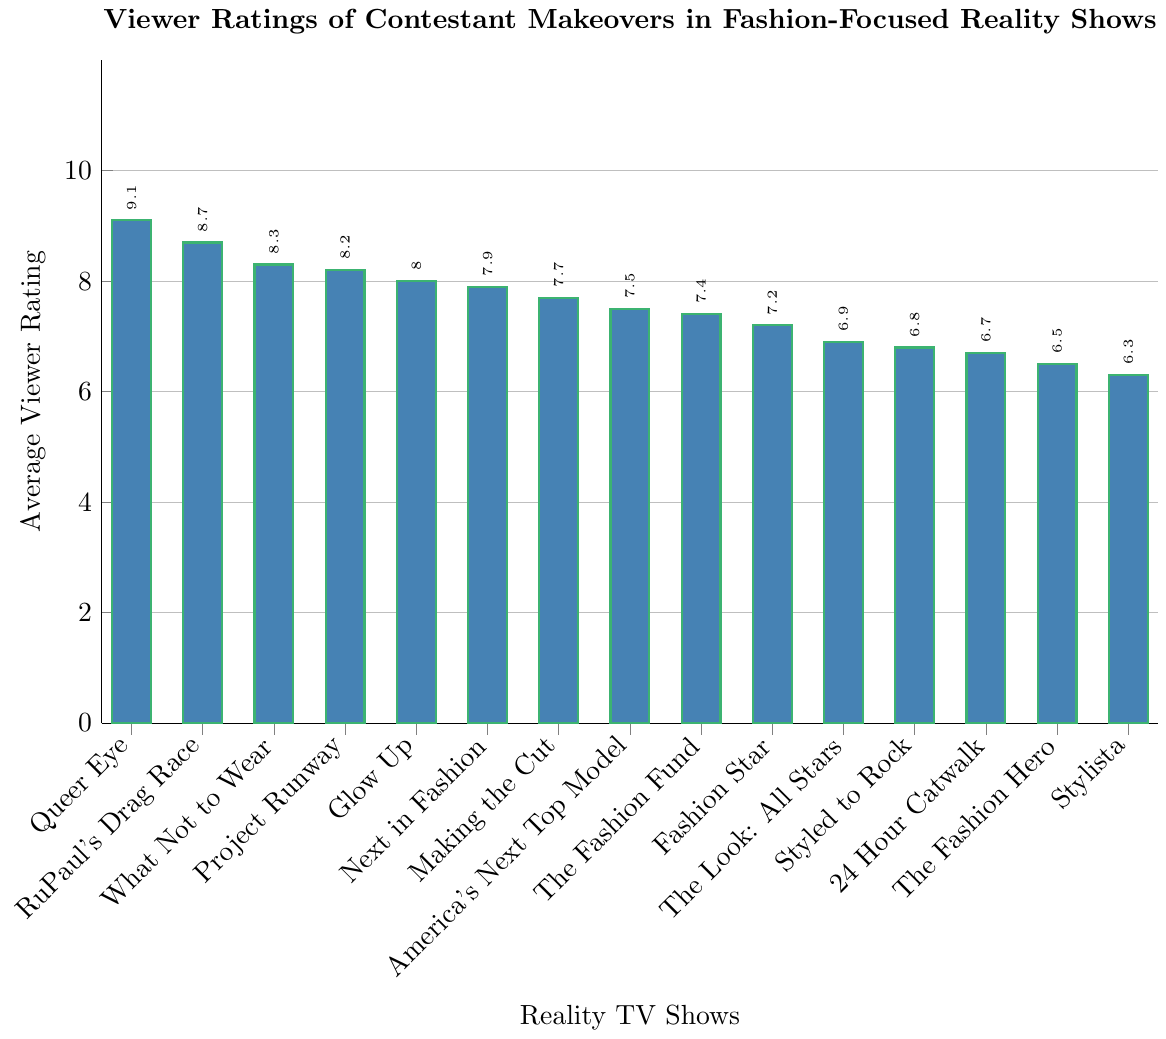What is the highest average viewer rating among the shows? The highest viewer rating is the tallest bar in the chart, labeled with its value. It belongs to "Queer Eye" with a height of 9.1.
Answer: 9.1 Which show has the lowest average viewer rating? The shortest bar in the chart represents the lowest rating. "Stylista" is the shortest bar with a value of 6.3.
Answer: 6.3 What is the difference in average viewer rating between "Project Runway" and "America's Next Top Model"? "Project Runway" has a rating of 8.2, and "America's Next Top Model" is at 7.5. The difference is calculated as 8.2 - 7.5.
Answer: 0.7 How many shows have an average viewer rating above 8.0? Count the bars that have heights exceeding the 8.0 mark. The shows are "Queer Eye", "RuPaul's Drag Race", "What Not to Wear", "Project Runway", and "Glow Up".
Answer: 5 Which has a higher average viewer rating: "Next in Fashion" or "Making the Cut"? Compare the heights of the bars for "Next in Fashion" and "Making the Cut". "Next in Fashion" has a rating of 7.9, while "Making the Cut" has 7.7.
Answer: Next in Fashion Between "What Not to Wear" and "Glow Up", which show has a higher rating and by how much? "What Not to Wear" has a rating of 8.3, and "Glow Up" has 8.0. The difference is calculated as 8.3 - 8.0.
Answer: What Not to Wear, 0.3 What is the average viewer rating of all shows combined? Add all the ratings and divide by the number of shows: (8.2 + 7.9 + 9.1 + 7.5 + 8.7 + 8.3 + 6.8 + 7.2 + 6.5 + 8.0 + 7.7 + 6.9 + 7.4 + 6.7 + 6.3) / 15. Sum is 113.2; average is 113.2 / 15.
Answer: 7.55 Which show is rated higher: "Styled to Rock" or "The Look: All Stars"? Compare the bars for "Styled to Rock" and "The Look: All Stars". "The Look: All Stars" has a rating of 6.9, and "Styled to Rock" has 6.8.
Answer: The Look: All Stars By how much does "RuPaul's Drag Race" exceed the average rating of "Styled to Rock"? "RuPaul's Drag Race" is rated 8.7, and "Styled to Rock" is rated 6.8. The difference is 8.7 - 6.8.
Answer: 1.9 